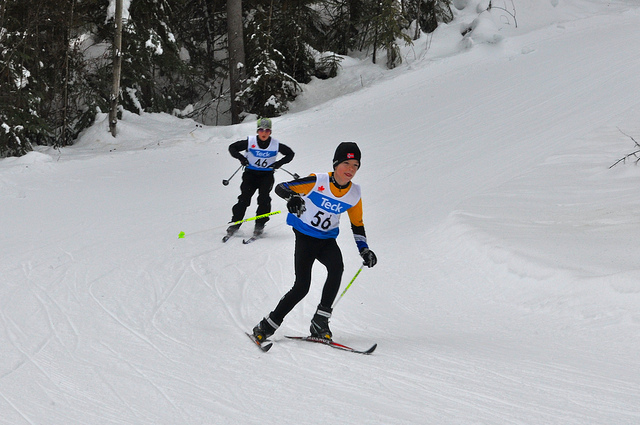Extract all visible text content from this image. 5 6 Teck 46 Track 